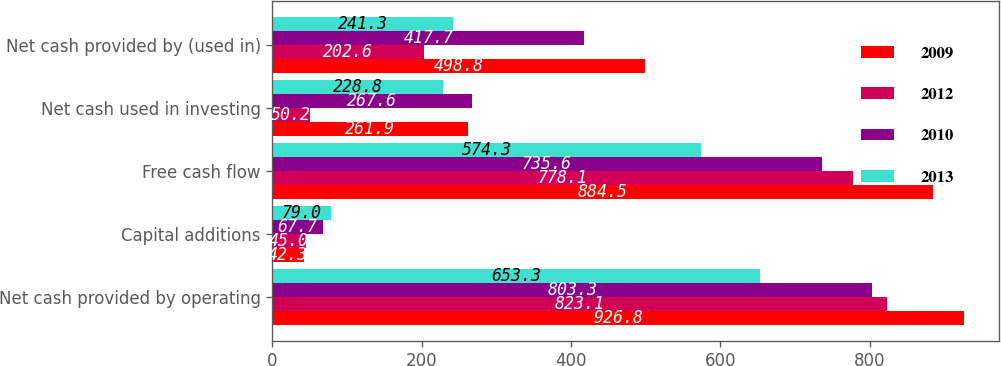Convert chart. <chart><loc_0><loc_0><loc_500><loc_500><stacked_bar_chart><ecel><fcel>Net cash provided by operating<fcel>Capital additions<fcel>Free cash flow<fcel>Net cash used in investing<fcel>Net cash provided by (used in)<nl><fcel>2009<fcel>926.8<fcel>42.3<fcel>884.5<fcel>261.9<fcel>498.8<nl><fcel>2012<fcel>823.1<fcel>45<fcel>778.1<fcel>50.2<fcel>202.6<nl><fcel>2010<fcel>803.3<fcel>67.7<fcel>735.6<fcel>267.6<fcel>417.7<nl><fcel>2013<fcel>653.3<fcel>79<fcel>574.3<fcel>228.8<fcel>241.3<nl></chart> 